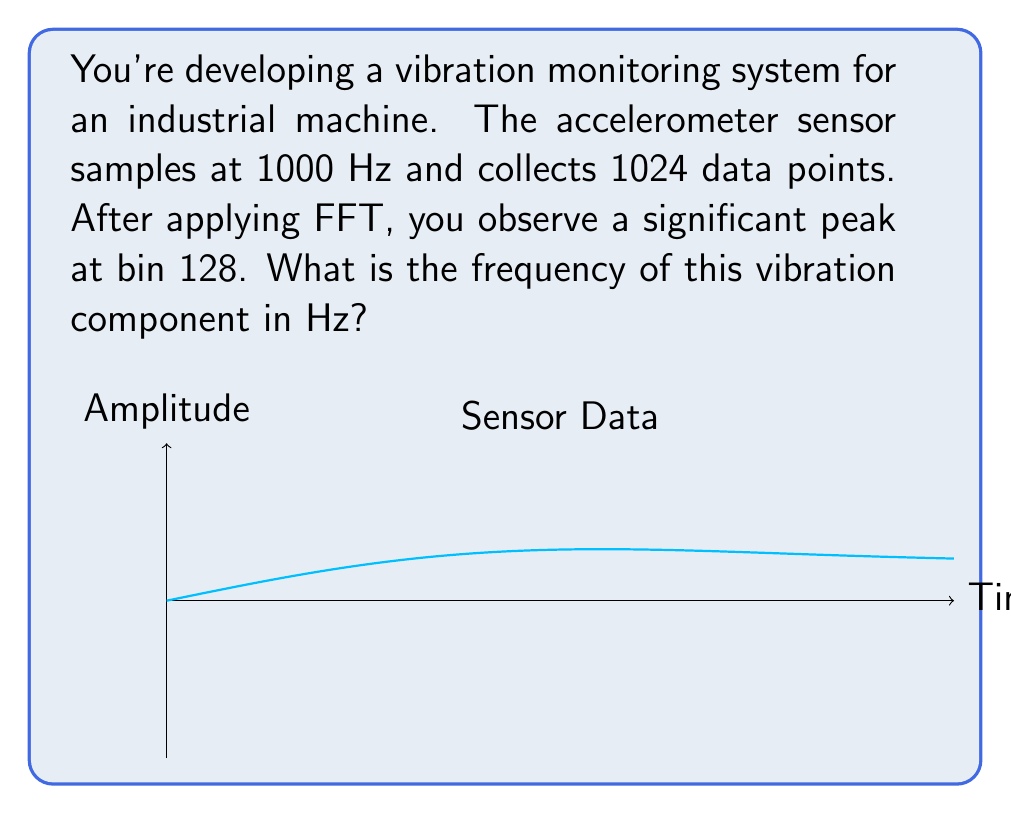Solve this math problem. To solve this problem, we'll follow these steps:

1. Understand the relationship between FFT bins and frequency:
   The number of FFT bins is equal to the number of data points (N). The frequency resolution (Δf) is given by:
   
   $$\Delta f = \frac{f_s}{N}$$
   
   where $f_s$ is the sampling frequency.

2. Calculate the frequency resolution:
   $$\Delta f = \frac{1000 \text{ Hz}}{1024} \approx 0.9766 \text{ Hz}$$

3. Determine the frequency corresponding to bin 128:
   The frequency of a given bin k is calculated as:
   
   $$f_k = k \cdot \Delta f$$
   
   For bin 128:
   $$f_{128} = 128 \cdot 0.9766 \text{ Hz} = 125 \text{ Hz}$$

Therefore, the vibration component has a frequency of 125 Hz.
Answer: 125 Hz 